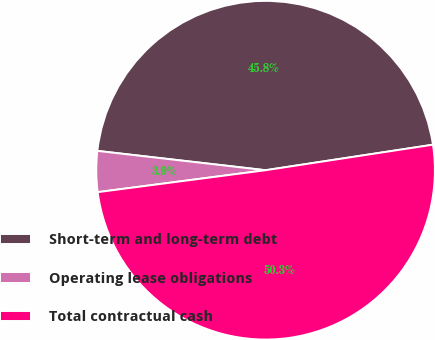Convert chart to OTSL. <chart><loc_0><loc_0><loc_500><loc_500><pie_chart><fcel>Short-term and long-term debt<fcel>Operating lease obligations<fcel>Total contractual cash<nl><fcel>45.77%<fcel>3.89%<fcel>50.34%<nl></chart> 